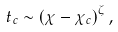<formula> <loc_0><loc_0><loc_500><loc_500>t _ { c } \sim \left ( \chi - \chi _ { c } \right ) ^ { \zeta } ,</formula> 